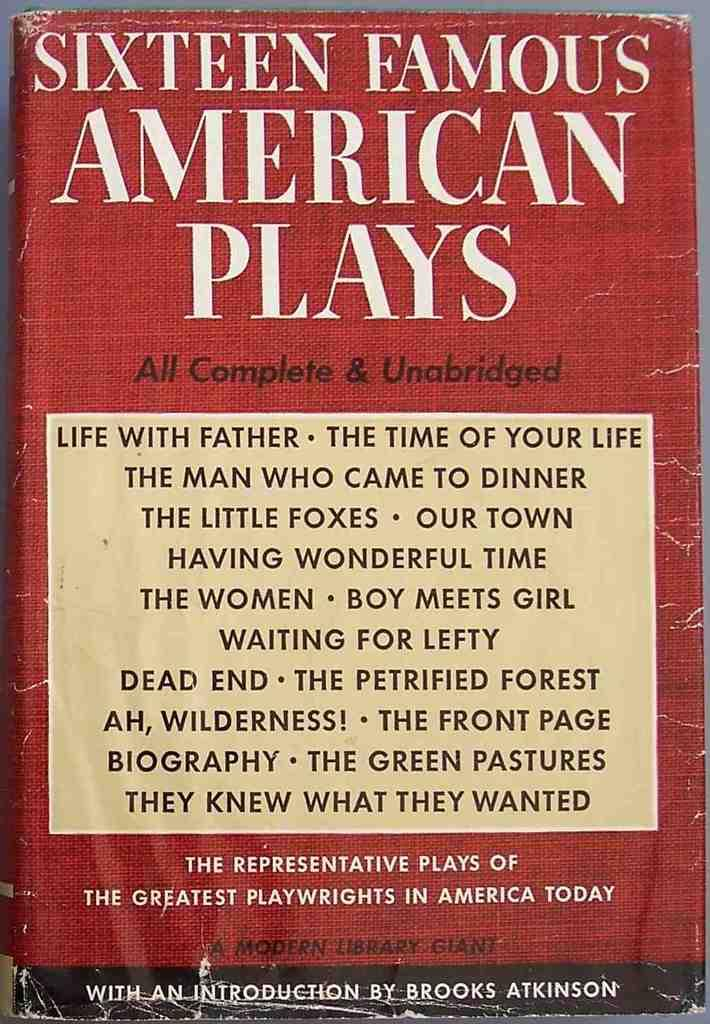Provide a one-sentence caption for the provided image. Sixteen Famous American Plays are compiled into a book. 